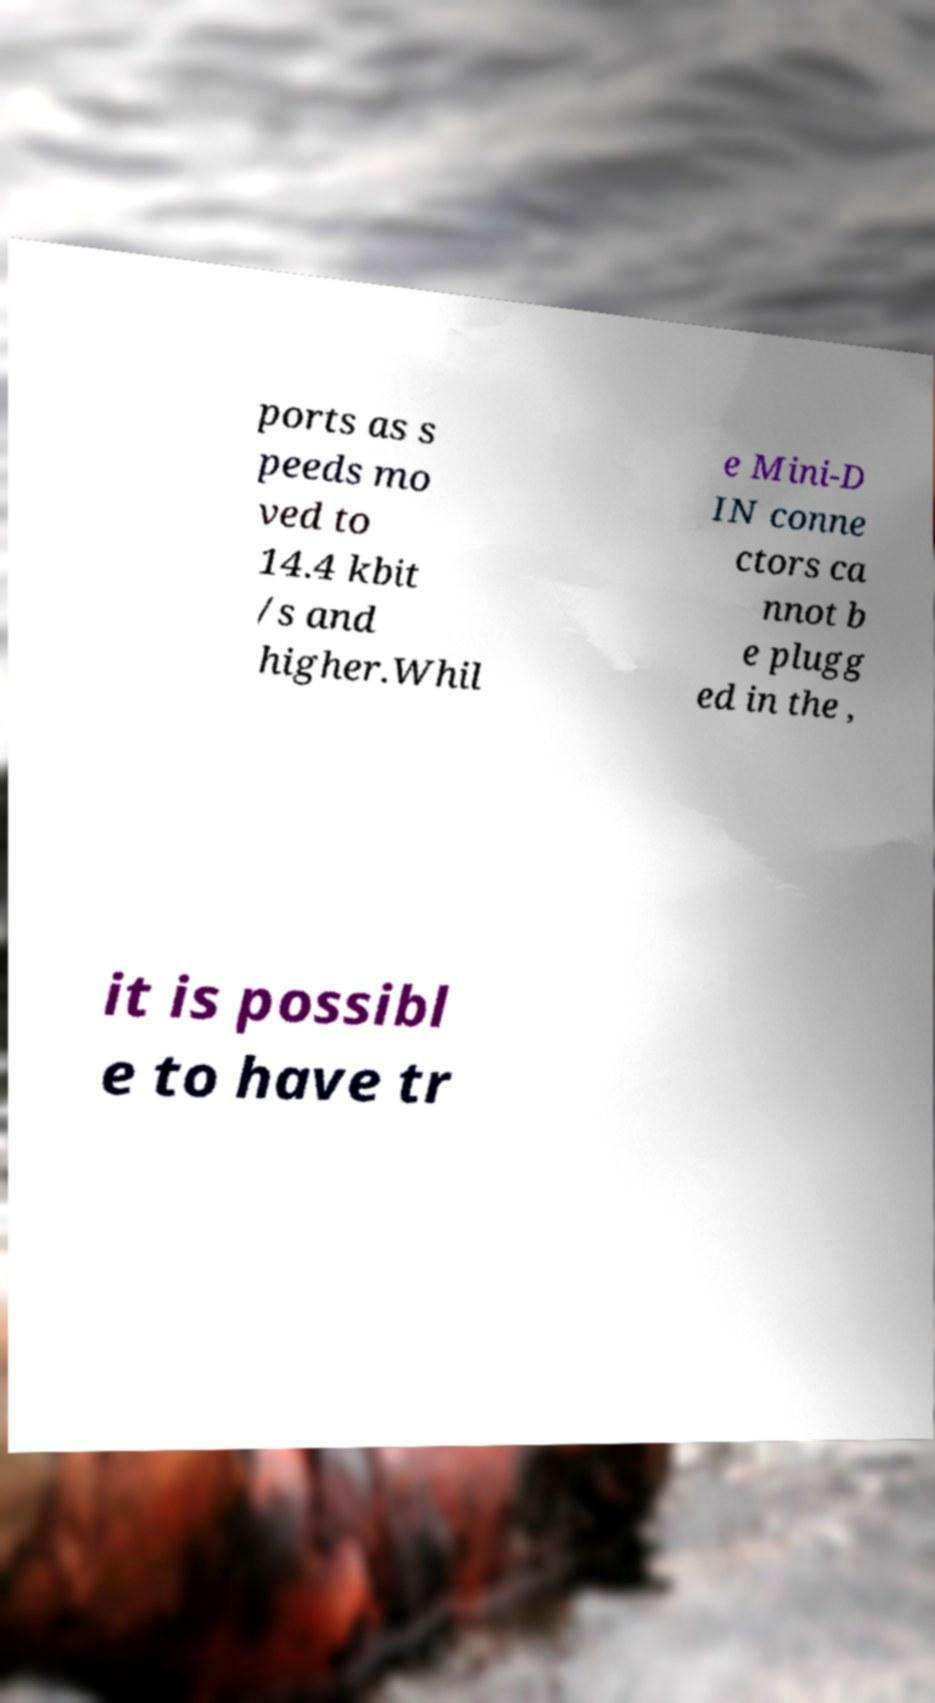There's text embedded in this image that I need extracted. Can you transcribe it verbatim? ports as s peeds mo ved to 14.4 kbit /s and higher.Whil e Mini-D IN conne ctors ca nnot b e plugg ed in the , it is possibl e to have tr 